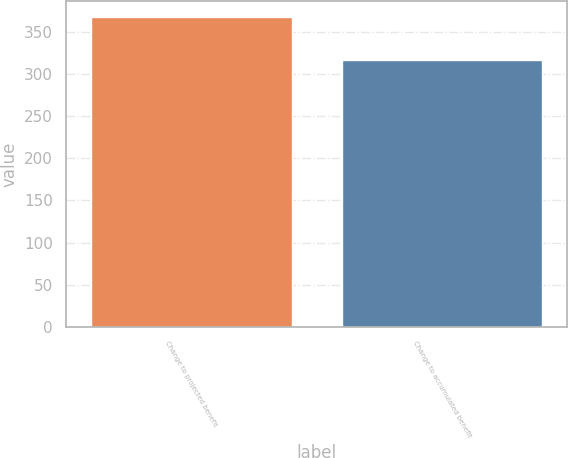<chart> <loc_0><loc_0><loc_500><loc_500><bar_chart><fcel>Change to projected benefit<fcel>Change to accumulated benefit<nl><fcel>368<fcel>317<nl></chart> 